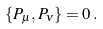Convert formula to latex. <formula><loc_0><loc_0><loc_500><loc_500>\{ P _ { \mu } , P _ { \nu } \} = 0 \, .</formula> 